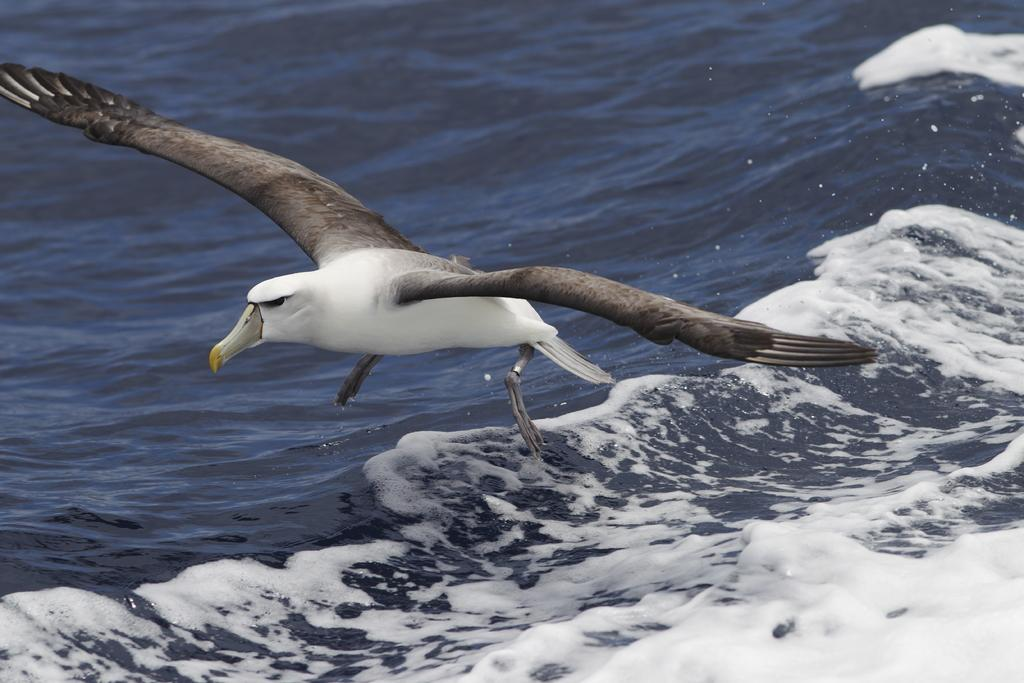What type of animal can be seen in the image? There is a bird in the image. What natural element is visible in the image? There is water visible in the image. What type of headphones can be seen on the bird's head in the image? There are no headphones present on the bird's head in the image. What type of side dish is served with the bird in the image? There is no side dish present with the bird in the image. 